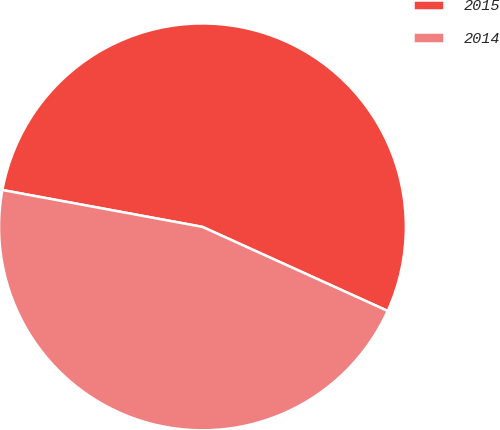Convert chart to OTSL. <chart><loc_0><loc_0><loc_500><loc_500><pie_chart><fcel>2015<fcel>2014<nl><fcel>53.88%<fcel>46.12%<nl></chart> 